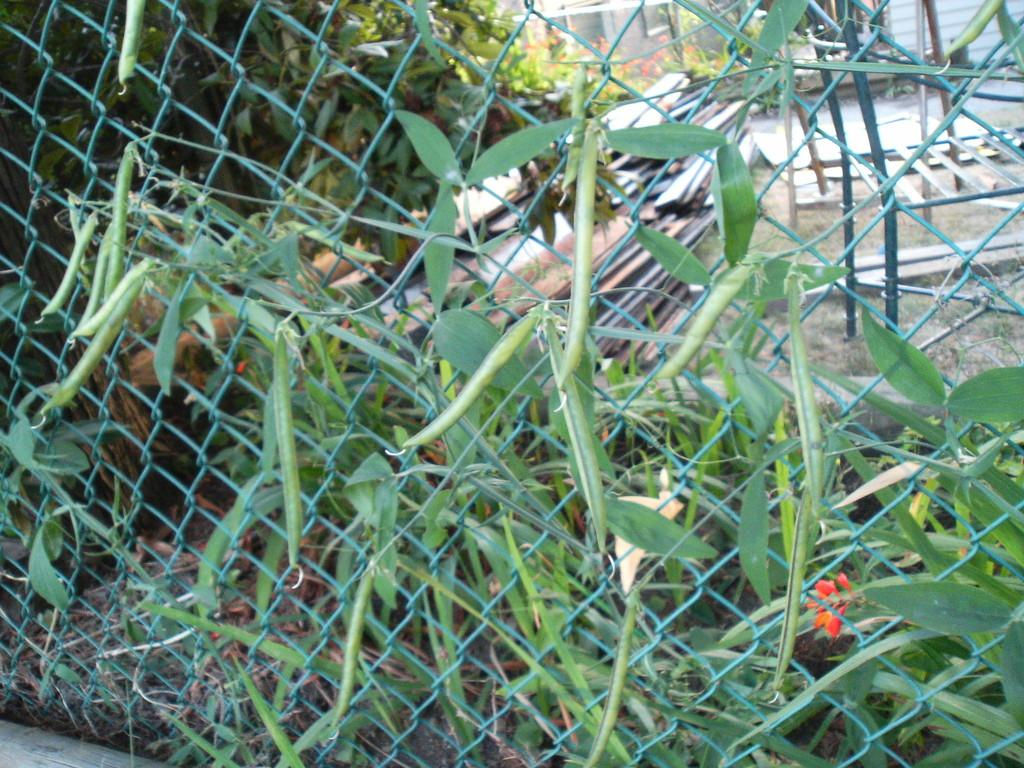What type of living organisms can be seen in the image? Plants can be seen in the image. What is the purpose of the fence in the image? The fence serves as a barrier or boundary in the image. What material are the metal objects made of? The metal objects in the image are made of metal. Can you describe the other objects on the ground in the image? Unfortunately, the provided facts do not specify the nature of the other objects on the ground. How many corn plants can be seen in the image? There is no mention of corn plants in the provided facts, so it cannot be determined from the image. --- Facts: 1. There is a person in the image. 2. The person is wearing a hat. 3. The person is holding a book. 4. There is a table in the image. 5. The table has a lamp on it. Absurd Topics: parrot, ocean, bicycle Conversation: What is the person in the image doing? The person in the image is holding a book. What is the person wearing on their head? The person in the image is wearing a hat. What object can be seen on the table in the image? There is a lamp on the table in the image. Reasoning: Let's think step by step in order to produce the conversation. We start by identifying the main subject in the image, which is the person. Then, we describe the person's actions and what they are wearing. Next, we focus on the table and describe the object on the table. We ensure that each question can be answered definitively with the information given. We avoid yes/no questions and ensure that the language is simple and clear. Absurd Question/Answer: Can you see a parrot sitting on the person's shoulder in the image? No, there is no parrot present in the image. 